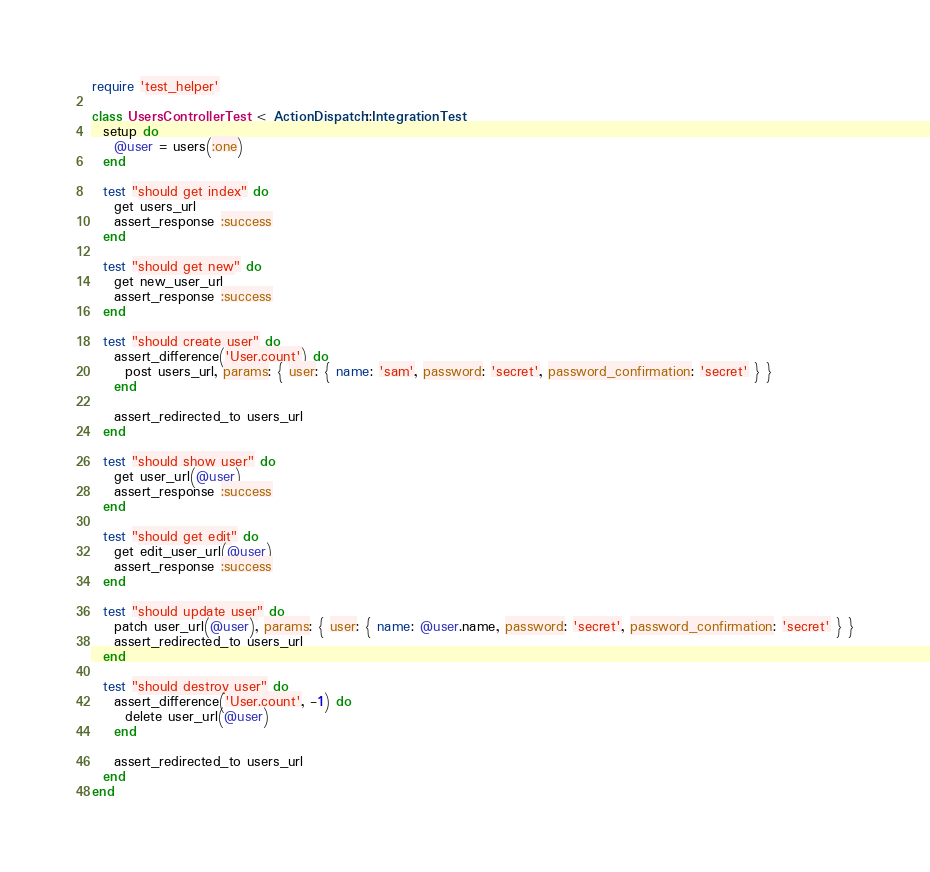<code> <loc_0><loc_0><loc_500><loc_500><_Ruby_>require 'test_helper'

class UsersControllerTest < ActionDispatch::IntegrationTest
  setup do
    @user = users(:one)
  end

  test "should get index" do
    get users_url
    assert_response :success
  end

  test "should get new" do
    get new_user_url
    assert_response :success
  end

  test "should create user" do
    assert_difference('User.count') do
      post users_url, params: { user: { name: 'sam', password: 'secret', password_confirmation: 'secret' } }
    end

    assert_redirected_to users_url
  end

  test "should show user" do
    get user_url(@user)
    assert_response :success
  end

  test "should get edit" do
    get edit_user_url(@user)
    assert_response :success
  end

  test "should update user" do
    patch user_url(@user), params: { user: { name: @user.name, password: 'secret', password_confirmation: 'secret' } }
    assert_redirected_to users_url
  end

  test "should destroy user" do
    assert_difference('User.count', -1) do
      delete user_url(@user)
    end

    assert_redirected_to users_url
  end
end
</code> 